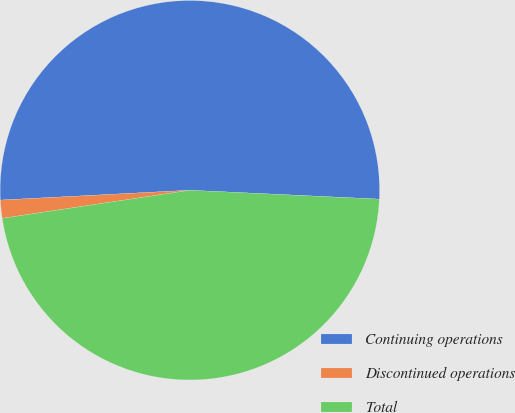Convert chart to OTSL. <chart><loc_0><loc_0><loc_500><loc_500><pie_chart><fcel>Continuing operations<fcel>Discontinued operations<fcel>Total<nl><fcel>51.57%<fcel>1.54%<fcel>46.88%<nl></chart> 